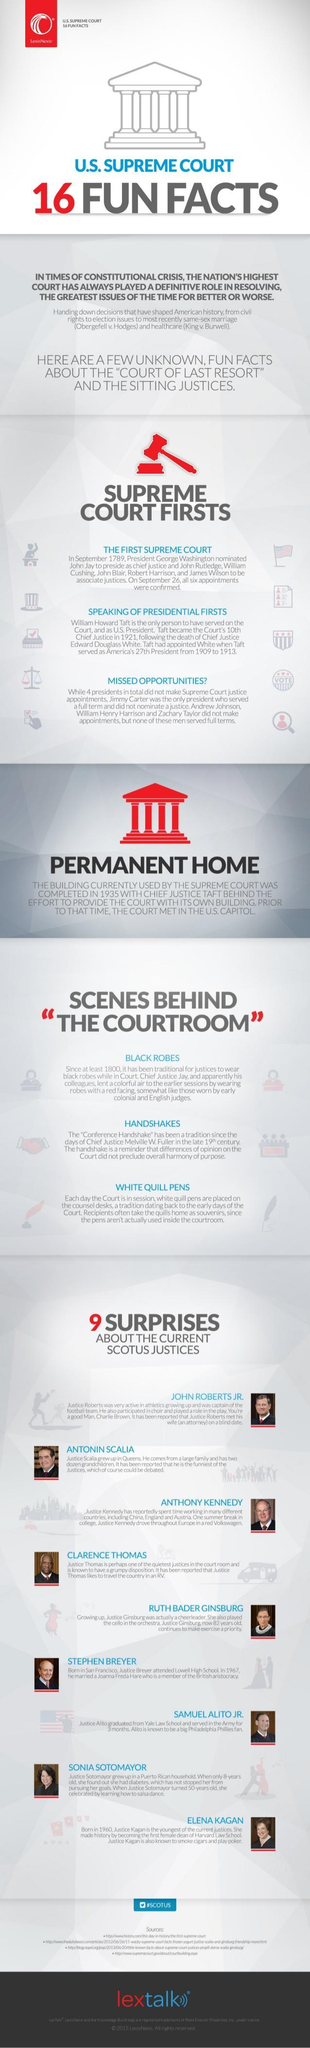what are not actually used inside the courtroon
Answer the question with a short phrase. white quill pens Who like to exercise Ruth Bader Ginsburg which scene speaks about dress black robes what is the colour of the hammer, red or white red who did taft replace Edward Douglass White which vehicle like Anthony Kennedy drive Volkswagen 